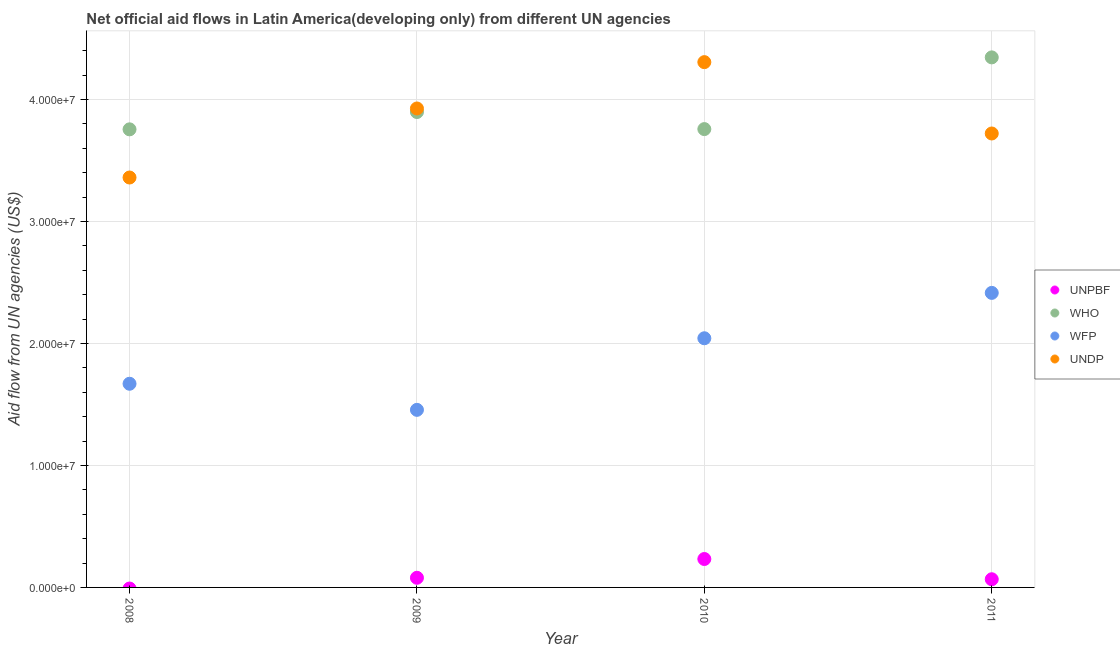Is the number of dotlines equal to the number of legend labels?
Provide a succinct answer. No. What is the amount of aid given by undp in 2009?
Give a very brief answer. 3.93e+07. Across all years, what is the maximum amount of aid given by unpbf?
Your answer should be very brief. 2.33e+06. In which year was the amount of aid given by unpbf maximum?
Your response must be concise. 2010. What is the total amount of aid given by undp in the graph?
Keep it short and to the point. 1.53e+08. What is the difference between the amount of aid given by who in 2008 and that in 2010?
Your response must be concise. -2.00e+04. What is the difference between the amount of aid given by who in 2011 and the amount of aid given by unpbf in 2010?
Make the answer very short. 4.11e+07. What is the average amount of aid given by wfp per year?
Provide a succinct answer. 1.90e+07. In the year 2010, what is the difference between the amount of aid given by undp and amount of aid given by who?
Your response must be concise. 5.49e+06. In how many years, is the amount of aid given by who greater than 10000000 US$?
Your answer should be very brief. 4. What is the ratio of the amount of aid given by wfp in 2010 to that in 2011?
Make the answer very short. 0.85. Is the amount of aid given by undp in 2009 less than that in 2010?
Your response must be concise. Yes. What is the difference between the highest and the second highest amount of aid given by undp?
Your answer should be compact. 3.80e+06. What is the difference between the highest and the lowest amount of aid given by who?
Offer a very short reply. 5.90e+06. Is it the case that in every year, the sum of the amount of aid given by unpbf and amount of aid given by who is greater than the amount of aid given by wfp?
Your answer should be very brief. Yes. Does the amount of aid given by undp monotonically increase over the years?
Keep it short and to the point. No. Is the amount of aid given by unpbf strictly greater than the amount of aid given by who over the years?
Give a very brief answer. No. Is the amount of aid given by who strictly less than the amount of aid given by unpbf over the years?
Offer a very short reply. No. How many dotlines are there?
Offer a very short reply. 4. Are the values on the major ticks of Y-axis written in scientific E-notation?
Give a very brief answer. Yes. Does the graph contain any zero values?
Your answer should be compact. Yes. Does the graph contain grids?
Offer a very short reply. Yes. Where does the legend appear in the graph?
Keep it short and to the point. Center right. How many legend labels are there?
Keep it short and to the point. 4. What is the title of the graph?
Give a very brief answer. Net official aid flows in Latin America(developing only) from different UN agencies. What is the label or title of the Y-axis?
Your answer should be very brief. Aid flow from UN agencies (US$). What is the Aid flow from UN agencies (US$) in WHO in 2008?
Your answer should be very brief. 3.76e+07. What is the Aid flow from UN agencies (US$) in WFP in 2008?
Give a very brief answer. 1.67e+07. What is the Aid flow from UN agencies (US$) in UNDP in 2008?
Provide a short and direct response. 3.36e+07. What is the Aid flow from UN agencies (US$) of UNPBF in 2009?
Your answer should be compact. 7.90e+05. What is the Aid flow from UN agencies (US$) in WHO in 2009?
Your answer should be compact. 3.90e+07. What is the Aid flow from UN agencies (US$) of WFP in 2009?
Offer a very short reply. 1.46e+07. What is the Aid flow from UN agencies (US$) in UNDP in 2009?
Ensure brevity in your answer.  3.93e+07. What is the Aid flow from UN agencies (US$) in UNPBF in 2010?
Your answer should be very brief. 2.33e+06. What is the Aid flow from UN agencies (US$) in WHO in 2010?
Your answer should be very brief. 3.76e+07. What is the Aid flow from UN agencies (US$) of WFP in 2010?
Make the answer very short. 2.04e+07. What is the Aid flow from UN agencies (US$) in UNDP in 2010?
Your response must be concise. 4.31e+07. What is the Aid flow from UN agencies (US$) in UNPBF in 2011?
Offer a terse response. 6.70e+05. What is the Aid flow from UN agencies (US$) of WHO in 2011?
Give a very brief answer. 4.35e+07. What is the Aid flow from UN agencies (US$) in WFP in 2011?
Offer a terse response. 2.42e+07. What is the Aid flow from UN agencies (US$) of UNDP in 2011?
Your response must be concise. 3.72e+07. Across all years, what is the maximum Aid flow from UN agencies (US$) of UNPBF?
Your answer should be very brief. 2.33e+06. Across all years, what is the maximum Aid flow from UN agencies (US$) of WHO?
Your answer should be very brief. 4.35e+07. Across all years, what is the maximum Aid flow from UN agencies (US$) of WFP?
Your answer should be very brief. 2.42e+07. Across all years, what is the maximum Aid flow from UN agencies (US$) of UNDP?
Give a very brief answer. 4.31e+07. Across all years, what is the minimum Aid flow from UN agencies (US$) in UNPBF?
Ensure brevity in your answer.  0. Across all years, what is the minimum Aid flow from UN agencies (US$) of WHO?
Your response must be concise. 3.76e+07. Across all years, what is the minimum Aid flow from UN agencies (US$) in WFP?
Keep it short and to the point. 1.46e+07. Across all years, what is the minimum Aid flow from UN agencies (US$) in UNDP?
Give a very brief answer. 3.36e+07. What is the total Aid flow from UN agencies (US$) in UNPBF in the graph?
Provide a short and direct response. 3.79e+06. What is the total Aid flow from UN agencies (US$) in WHO in the graph?
Give a very brief answer. 1.58e+08. What is the total Aid flow from UN agencies (US$) of WFP in the graph?
Your response must be concise. 7.58e+07. What is the total Aid flow from UN agencies (US$) of UNDP in the graph?
Offer a very short reply. 1.53e+08. What is the difference between the Aid flow from UN agencies (US$) of WHO in 2008 and that in 2009?
Ensure brevity in your answer.  -1.42e+06. What is the difference between the Aid flow from UN agencies (US$) in WFP in 2008 and that in 2009?
Provide a succinct answer. 2.14e+06. What is the difference between the Aid flow from UN agencies (US$) of UNDP in 2008 and that in 2009?
Give a very brief answer. -5.66e+06. What is the difference between the Aid flow from UN agencies (US$) in WFP in 2008 and that in 2010?
Give a very brief answer. -3.73e+06. What is the difference between the Aid flow from UN agencies (US$) in UNDP in 2008 and that in 2010?
Your answer should be compact. -9.46e+06. What is the difference between the Aid flow from UN agencies (US$) in WHO in 2008 and that in 2011?
Your answer should be compact. -5.90e+06. What is the difference between the Aid flow from UN agencies (US$) in WFP in 2008 and that in 2011?
Provide a short and direct response. -7.45e+06. What is the difference between the Aid flow from UN agencies (US$) in UNDP in 2008 and that in 2011?
Offer a very short reply. -3.61e+06. What is the difference between the Aid flow from UN agencies (US$) of UNPBF in 2009 and that in 2010?
Give a very brief answer. -1.54e+06. What is the difference between the Aid flow from UN agencies (US$) of WHO in 2009 and that in 2010?
Your answer should be compact. 1.40e+06. What is the difference between the Aid flow from UN agencies (US$) in WFP in 2009 and that in 2010?
Your response must be concise. -5.87e+06. What is the difference between the Aid flow from UN agencies (US$) of UNDP in 2009 and that in 2010?
Make the answer very short. -3.80e+06. What is the difference between the Aid flow from UN agencies (US$) of WHO in 2009 and that in 2011?
Keep it short and to the point. -4.48e+06. What is the difference between the Aid flow from UN agencies (US$) in WFP in 2009 and that in 2011?
Offer a very short reply. -9.59e+06. What is the difference between the Aid flow from UN agencies (US$) of UNDP in 2009 and that in 2011?
Provide a succinct answer. 2.05e+06. What is the difference between the Aid flow from UN agencies (US$) of UNPBF in 2010 and that in 2011?
Give a very brief answer. 1.66e+06. What is the difference between the Aid flow from UN agencies (US$) in WHO in 2010 and that in 2011?
Make the answer very short. -5.88e+06. What is the difference between the Aid flow from UN agencies (US$) in WFP in 2010 and that in 2011?
Provide a succinct answer. -3.72e+06. What is the difference between the Aid flow from UN agencies (US$) of UNDP in 2010 and that in 2011?
Your answer should be very brief. 5.85e+06. What is the difference between the Aid flow from UN agencies (US$) in WHO in 2008 and the Aid flow from UN agencies (US$) in WFP in 2009?
Keep it short and to the point. 2.30e+07. What is the difference between the Aid flow from UN agencies (US$) of WHO in 2008 and the Aid flow from UN agencies (US$) of UNDP in 2009?
Your answer should be compact. -1.71e+06. What is the difference between the Aid flow from UN agencies (US$) of WFP in 2008 and the Aid flow from UN agencies (US$) of UNDP in 2009?
Keep it short and to the point. -2.26e+07. What is the difference between the Aid flow from UN agencies (US$) in WHO in 2008 and the Aid flow from UN agencies (US$) in WFP in 2010?
Your answer should be compact. 1.71e+07. What is the difference between the Aid flow from UN agencies (US$) in WHO in 2008 and the Aid flow from UN agencies (US$) in UNDP in 2010?
Ensure brevity in your answer.  -5.51e+06. What is the difference between the Aid flow from UN agencies (US$) in WFP in 2008 and the Aid flow from UN agencies (US$) in UNDP in 2010?
Give a very brief answer. -2.64e+07. What is the difference between the Aid flow from UN agencies (US$) of WHO in 2008 and the Aid flow from UN agencies (US$) of WFP in 2011?
Your response must be concise. 1.34e+07. What is the difference between the Aid flow from UN agencies (US$) of WHO in 2008 and the Aid flow from UN agencies (US$) of UNDP in 2011?
Offer a terse response. 3.40e+05. What is the difference between the Aid flow from UN agencies (US$) of WFP in 2008 and the Aid flow from UN agencies (US$) of UNDP in 2011?
Your answer should be very brief. -2.05e+07. What is the difference between the Aid flow from UN agencies (US$) of UNPBF in 2009 and the Aid flow from UN agencies (US$) of WHO in 2010?
Provide a succinct answer. -3.68e+07. What is the difference between the Aid flow from UN agencies (US$) of UNPBF in 2009 and the Aid flow from UN agencies (US$) of WFP in 2010?
Your response must be concise. -1.96e+07. What is the difference between the Aid flow from UN agencies (US$) in UNPBF in 2009 and the Aid flow from UN agencies (US$) in UNDP in 2010?
Your answer should be compact. -4.23e+07. What is the difference between the Aid flow from UN agencies (US$) of WHO in 2009 and the Aid flow from UN agencies (US$) of WFP in 2010?
Offer a terse response. 1.86e+07. What is the difference between the Aid flow from UN agencies (US$) in WHO in 2009 and the Aid flow from UN agencies (US$) in UNDP in 2010?
Offer a very short reply. -4.09e+06. What is the difference between the Aid flow from UN agencies (US$) in WFP in 2009 and the Aid flow from UN agencies (US$) in UNDP in 2010?
Ensure brevity in your answer.  -2.85e+07. What is the difference between the Aid flow from UN agencies (US$) of UNPBF in 2009 and the Aid flow from UN agencies (US$) of WHO in 2011?
Your response must be concise. -4.27e+07. What is the difference between the Aid flow from UN agencies (US$) in UNPBF in 2009 and the Aid flow from UN agencies (US$) in WFP in 2011?
Your answer should be compact. -2.34e+07. What is the difference between the Aid flow from UN agencies (US$) in UNPBF in 2009 and the Aid flow from UN agencies (US$) in UNDP in 2011?
Offer a terse response. -3.64e+07. What is the difference between the Aid flow from UN agencies (US$) in WHO in 2009 and the Aid flow from UN agencies (US$) in WFP in 2011?
Offer a terse response. 1.48e+07. What is the difference between the Aid flow from UN agencies (US$) in WHO in 2009 and the Aid flow from UN agencies (US$) in UNDP in 2011?
Make the answer very short. 1.76e+06. What is the difference between the Aid flow from UN agencies (US$) in WFP in 2009 and the Aid flow from UN agencies (US$) in UNDP in 2011?
Your answer should be very brief. -2.27e+07. What is the difference between the Aid flow from UN agencies (US$) in UNPBF in 2010 and the Aid flow from UN agencies (US$) in WHO in 2011?
Offer a very short reply. -4.11e+07. What is the difference between the Aid flow from UN agencies (US$) in UNPBF in 2010 and the Aid flow from UN agencies (US$) in WFP in 2011?
Provide a succinct answer. -2.18e+07. What is the difference between the Aid flow from UN agencies (US$) of UNPBF in 2010 and the Aid flow from UN agencies (US$) of UNDP in 2011?
Keep it short and to the point. -3.49e+07. What is the difference between the Aid flow from UN agencies (US$) in WHO in 2010 and the Aid flow from UN agencies (US$) in WFP in 2011?
Ensure brevity in your answer.  1.34e+07. What is the difference between the Aid flow from UN agencies (US$) of WHO in 2010 and the Aid flow from UN agencies (US$) of UNDP in 2011?
Your response must be concise. 3.60e+05. What is the difference between the Aid flow from UN agencies (US$) in WFP in 2010 and the Aid flow from UN agencies (US$) in UNDP in 2011?
Your answer should be very brief. -1.68e+07. What is the average Aid flow from UN agencies (US$) of UNPBF per year?
Provide a short and direct response. 9.48e+05. What is the average Aid flow from UN agencies (US$) of WHO per year?
Keep it short and to the point. 3.94e+07. What is the average Aid flow from UN agencies (US$) of WFP per year?
Give a very brief answer. 1.90e+07. What is the average Aid flow from UN agencies (US$) of UNDP per year?
Provide a short and direct response. 3.83e+07. In the year 2008, what is the difference between the Aid flow from UN agencies (US$) of WHO and Aid flow from UN agencies (US$) of WFP?
Offer a terse response. 2.09e+07. In the year 2008, what is the difference between the Aid flow from UN agencies (US$) in WHO and Aid flow from UN agencies (US$) in UNDP?
Your response must be concise. 3.95e+06. In the year 2008, what is the difference between the Aid flow from UN agencies (US$) in WFP and Aid flow from UN agencies (US$) in UNDP?
Offer a very short reply. -1.69e+07. In the year 2009, what is the difference between the Aid flow from UN agencies (US$) in UNPBF and Aid flow from UN agencies (US$) in WHO?
Your response must be concise. -3.82e+07. In the year 2009, what is the difference between the Aid flow from UN agencies (US$) of UNPBF and Aid flow from UN agencies (US$) of WFP?
Ensure brevity in your answer.  -1.38e+07. In the year 2009, what is the difference between the Aid flow from UN agencies (US$) of UNPBF and Aid flow from UN agencies (US$) of UNDP?
Give a very brief answer. -3.85e+07. In the year 2009, what is the difference between the Aid flow from UN agencies (US$) of WHO and Aid flow from UN agencies (US$) of WFP?
Give a very brief answer. 2.44e+07. In the year 2009, what is the difference between the Aid flow from UN agencies (US$) in WHO and Aid flow from UN agencies (US$) in UNDP?
Make the answer very short. -2.90e+05. In the year 2009, what is the difference between the Aid flow from UN agencies (US$) of WFP and Aid flow from UN agencies (US$) of UNDP?
Keep it short and to the point. -2.47e+07. In the year 2010, what is the difference between the Aid flow from UN agencies (US$) in UNPBF and Aid flow from UN agencies (US$) in WHO?
Your answer should be compact. -3.52e+07. In the year 2010, what is the difference between the Aid flow from UN agencies (US$) of UNPBF and Aid flow from UN agencies (US$) of WFP?
Make the answer very short. -1.81e+07. In the year 2010, what is the difference between the Aid flow from UN agencies (US$) in UNPBF and Aid flow from UN agencies (US$) in UNDP?
Give a very brief answer. -4.07e+07. In the year 2010, what is the difference between the Aid flow from UN agencies (US$) in WHO and Aid flow from UN agencies (US$) in WFP?
Provide a short and direct response. 1.72e+07. In the year 2010, what is the difference between the Aid flow from UN agencies (US$) of WHO and Aid flow from UN agencies (US$) of UNDP?
Ensure brevity in your answer.  -5.49e+06. In the year 2010, what is the difference between the Aid flow from UN agencies (US$) in WFP and Aid flow from UN agencies (US$) in UNDP?
Keep it short and to the point. -2.26e+07. In the year 2011, what is the difference between the Aid flow from UN agencies (US$) in UNPBF and Aid flow from UN agencies (US$) in WHO?
Keep it short and to the point. -4.28e+07. In the year 2011, what is the difference between the Aid flow from UN agencies (US$) in UNPBF and Aid flow from UN agencies (US$) in WFP?
Your response must be concise. -2.35e+07. In the year 2011, what is the difference between the Aid flow from UN agencies (US$) of UNPBF and Aid flow from UN agencies (US$) of UNDP?
Make the answer very short. -3.66e+07. In the year 2011, what is the difference between the Aid flow from UN agencies (US$) in WHO and Aid flow from UN agencies (US$) in WFP?
Provide a succinct answer. 1.93e+07. In the year 2011, what is the difference between the Aid flow from UN agencies (US$) in WHO and Aid flow from UN agencies (US$) in UNDP?
Offer a terse response. 6.24e+06. In the year 2011, what is the difference between the Aid flow from UN agencies (US$) in WFP and Aid flow from UN agencies (US$) in UNDP?
Give a very brief answer. -1.31e+07. What is the ratio of the Aid flow from UN agencies (US$) of WHO in 2008 to that in 2009?
Your answer should be compact. 0.96. What is the ratio of the Aid flow from UN agencies (US$) in WFP in 2008 to that in 2009?
Your answer should be compact. 1.15. What is the ratio of the Aid flow from UN agencies (US$) of UNDP in 2008 to that in 2009?
Offer a terse response. 0.86. What is the ratio of the Aid flow from UN agencies (US$) in WFP in 2008 to that in 2010?
Make the answer very short. 0.82. What is the ratio of the Aid flow from UN agencies (US$) of UNDP in 2008 to that in 2010?
Provide a succinct answer. 0.78. What is the ratio of the Aid flow from UN agencies (US$) in WHO in 2008 to that in 2011?
Offer a very short reply. 0.86. What is the ratio of the Aid flow from UN agencies (US$) of WFP in 2008 to that in 2011?
Your answer should be very brief. 0.69. What is the ratio of the Aid flow from UN agencies (US$) of UNDP in 2008 to that in 2011?
Give a very brief answer. 0.9. What is the ratio of the Aid flow from UN agencies (US$) of UNPBF in 2009 to that in 2010?
Provide a short and direct response. 0.34. What is the ratio of the Aid flow from UN agencies (US$) of WHO in 2009 to that in 2010?
Your answer should be compact. 1.04. What is the ratio of the Aid flow from UN agencies (US$) of WFP in 2009 to that in 2010?
Keep it short and to the point. 0.71. What is the ratio of the Aid flow from UN agencies (US$) of UNDP in 2009 to that in 2010?
Your answer should be compact. 0.91. What is the ratio of the Aid flow from UN agencies (US$) of UNPBF in 2009 to that in 2011?
Offer a very short reply. 1.18. What is the ratio of the Aid flow from UN agencies (US$) of WHO in 2009 to that in 2011?
Your answer should be very brief. 0.9. What is the ratio of the Aid flow from UN agencies (US$) of WFP in 2009 to that in 2011?
Give a very brief answer. 0.6. What is the ratio of the Aid flow from UN agencies (US$) of UNDP in 2009 to that in 2011?
Your response must be concise. 1.06. What is the ratio of the Aid flow from UN agencies (US$) of UNPBF in 2010 to that in 2011?
Keep it short and to the point. 3.48. What is the ratio of the Aid flow from UN agencies (US$) of WHO in 2010 to that in 2011?
Your answer should be very brief. 0.86. What is the ratio of the Aid flow from UN agencies (US$) in WFP in 2010 to that in 2011?
Your answer should be compact. 0.85. What is the ratio of the Aid flow from UN agencies (US$) of UNDP in 2010 to that in 2011?
Make the answer very short. 1.16. What is the difference between the highest and the second highest Aid flow from UN agencies (US$) in UNPBF?
Your answer should be very brief. 1.54e+06. What is the difference between the highest and the second highest Aid flow from UN agencies (US$) in WHO?
Provide a succinct answer. 4.48e+06. What is the difference between the highest and the second highest Aid flow from UN agencies (US$) in WFP?
Make the answer very short. 3.72e+06. What is the difference between the highest and the second highest Aid flow from UN agencies (US$) in UNDP?
Offer a terse response. 3.80e+06. What is the difference between the highest and the lowest Aid flow from UN agencies (US$) in UNPBF?
Provide a short and direct response. 2.33e+06. What is the difference between the highest and the lowest Aid flow from UN agencies (US$) in WHO?
Ensure brevity in your answer.  5.90e+06. What is the difference between the highest and the lowest Aid flow from UN agencies (US$) in WFP?
Provide a succinct answer. 9.59e+06. What is the difference between the highest and the lowest Aid flow from UN agencies (US$) of UNDP?
Make the answer very short. 9.46e+06. 